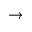<formula> <loc_0><loc_0><loc_500><loc_500>\rightarrow</formula> 